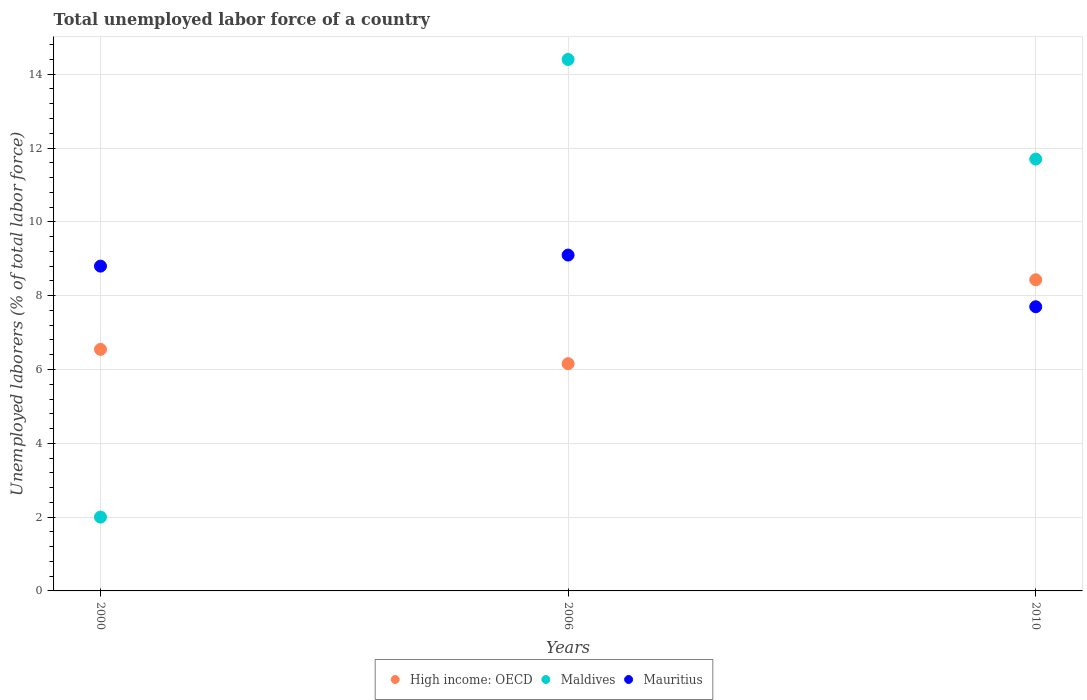How many different coloured dotlines are there?
Offer a very short reply. 3. What is the total unemployed labor force in Mauritius in 2010?
Your answer should be very brief. 7.7. Across all years, what is the maximum total unemployed labor force in High income: OECD?
Provide a succinct answer. 8.43. Across all years, what is the minimum total unemployed labor force in High income: OECD?
Ensure brevity in your answer.  6.16. In which year was the total unemployed labor force in Maldives maximum?
Your response must be concise. 2006. What is the total total unemployed labor force in Mauritius in the graph?
Your answer should be compact. 25.6. What is the difference between the total unemployed labor force in High income: OECD in 2000 and that in 2010?
Provide a short and direct response. -1.89. What is the difference between the total unemployed labor force in Maldives in 2000 and the total unemployed labor force in High income: OECD in 2010?
Your answer should be very brief. -6.43. What is the average total unemployed labor force in Mauritius per year?
Keep it short and to the point. 8.53. In the year 2006, what is the difference between the total unemployed labor force in Mauritius and total unemployed labor force in Maldives?
Provide a short and direct response. -5.3. In how many years, is the total unemployed labor force in High income: OECD greater than 10.4 %?
Ensure brevity in your answer.  0. What is the ratio of the total unemployed labor force in Mauritius in 2006 to that in 2010?
Provide a succinct answer. 1.18. Is the total unemployed labor force in Mauritius in 2006 less than that in 2010?
Make the answer very short. No. What is the difference between the highest and the second highest total unemployed labor force in High income: OECD?
Make the answer very short. 1.89. What is the difference between the highest and the lowest total unemployed labor force in High income: OECD?
Keep it short and to the point. 2.27. Is it the case that in every year, the sum of the total unemployed labor force in Mauritius and total unemployed labor force in High income: OECD  is greater than the total unemployed labor force in Maldives?
Provide a short and direct response. Yes. Does the total unemployed labor force in Maldives monotonically increase over the years?
Your answer should be very brief. No. Is the total unemployed labor force in High income: OECD strictly less than the total unemployed labor force in Mauritius over the years?
Your response must be concise. No. How many dotlines are there?
Offer a terse response. 3. How many years are there in the graph?
Make the answer very short. 3. What is the difference between two consecutive major ticks on the Y-axis?
Your answer should be very brief. 2. Does the graph contain any zero values?
Keep it short and to the point. No. What is the title of the graph?
Your answer should be compact. Total unemployed labor force of a country. What is the label or title of the X-axis?
Provide a succinct answer. Years. What is the label or title of the Y-axis?
Offer a very short reply. Unemployed laborers (% of total labor force). What is the Unemployed laborers (% of total labor force) in High income: OECD in 2000?
Offer a terse response. 6.54. What is the Unemployed laborers (% of total labor force) in Mauritius in 2000?
Give a very brief answer. 8.8. What is the Unemployed laborers (% of total labor force) in High income: OECD in 2006?
Ensure brevity in your answer.  6.16. What is the Unemployed laborers (% of total labor force) in Maldives in 2006?
Your answer should be very brief. 14.4. What is the Unemployed laborers (% of total labor force) in Mauritius in 2006?
Make the answer very short. 9.1. What is the Unemployed laborers (% of total labor force) of High income: OECD in 2010?
Your answer should be compact. 8.43. What is the Unemployed laborers (% of total labor force) in Maldives in 2010?
Provide a short and direct response. 11.7. What is the Unemployed laborers (% of total labor force) in Mauritius in 2010?
Offer a terse response. 7.7. Across all years, what is the maximum Unemployed laborers (% of total labor force) in High income: OECD?
Your answer should be compact. 8.43. Across all years, what is the maximum Unemployed laborers (% of total labor force) in Maldives?
Your answer should be compact. 14.4. Across all years, what is the maximum Unemployed laborers (% of total labor force) in Mauritius?
Provide a short and direct response. 9.1. Across all years, what is the minimum Unemployed laborers (% of total labor force) of High income: OECD?
Give a very brief answer. 6.16. Across all years, what is the minimum Unemployed laborers (% of total labor force) of Mauritius?
Offer a terse response. 7.7. What is the total Unemployed laborers (% of total labor force) in High income: OECD in the graph?
Keep it short and to the point. 21.13. What is the total Unemployed laborers (% of total labor force) in Maldives in the graph?
Your answer should be compact. 28.1. What is the total Unemployed laborers (% of total labor force) of Mauritius in the graph?
Provide a short and direct response. 25.6. What is the difference between the Unemployed laborers (% of total labor force) of High income: OECD in 2000 and that in 2006?
Provide a short and direct response. 0.39. What is the difference between the Unemployed laborers (% of total labor force) of Maldives in 2000 and that in 2006?
Your answer should be very brief. -12.4. What is the difference between the Unemployed laborers (% of total labor force) of High income: OECD in 2000 and that in 2010?
Give a very brief answer. -1.89. What is the difference between the Unemployed laborers (% of total labor force) in Maldives in 2000 and that in 2010?
Ensure brevity in your answer.  -9.7. What is the difference between the Unemployed laborers (% of total labor force) in Mauritius in 2000 and that in 2010?
Your answer should be very brief. 1.1. What is the difference between the Unemployed laborers (% of total labor force) of High income: OECD in 2006 and that in 2010?
Your response must be concise. -2.27. What is the difference between the Unemployed laborers (% of total labor force) in Maldives in 2006 and that in 2010?
Your response must be concise. 2.7. What is the difference between the Unemployed laborers (% of total labor force) of Mauritius in 2006 and that in 2010?
Make the answer very short. 1.4. What is the difference between the Unemployed laborers (% of total labor force) in High income: OECD in 2000 and the Unemployed laborers (% of total labor force) in Maldives in 2006?
Make the answer very short. -7.86. What is the difference between the Unemployed laborers (% of total labor force) in High income: OECD in 2000 and the Unemployed laborers (% of total labor force) in Mauritius in 2006?
Ensure brevity in your answer.  -2.56. What is the difference between the Unemployed laborers (% of total labor force) of High income: OECD in 2000 and the Unemployed laborers (% of total labor force) of Maldives in 2010?
Keep it short and to the point. -5.16. What is the difference between the Unemployed laborers (% of total labor force) in High income: OECD in 2000 and the Unemployed laborers (% of total labor force) in Mauritius in 2010?
Your response must be concise. -1.16. What is the difference between the Unemployed laborers (% of total labor force) in High income: OECD in 2006 and the Unemployed laborers (% of total labor force) in Maldives in 2010?
Provide a short and direct response. -5.54. What is the difference between the Unemployed laborers (% of total labor force) of High income: OECD in 2006 and the Unemployed laborers (% of total labor force) of Mauritius in 2010?
Ensure brevity in your answer.  -1.54. What is the average Unemployed laborers (% of total labor force) in High income: OECD per year?
Your answer should be very brief. 7.04. What is the average Unemployed laborers (% of total labor force) of Maldives per year?
Your response must be concise. 9.37. What is the average Unemployed laborers (% of total labor force) in Mauritius per year?
Ensure brevity in your answer.  8.53. In the year 2000, what is the difference between the Unemployed laborers (% of total labor force) in High income: OECD and Unemployed laborers (% of total labor force) in Maldives?
Offer a very short reply. 4.54. In the year 2000, what is the difference between the Unemployed laborers (% of total labor force) in High income: OECD and Unemployed laborers (% of total labor force) in Mauritius?
Your response must be concise. -2.26. In the year 2006, what is the difference between the Unemployed laborers (% of total labor force) of High income: OECD and Unemployed laborers (% of total labor force) of Maldives?
Make the answer very short. -8.24. In the year 2006, what is the difference between the Unemployed laborers (% of total labor force) in High income: OECD and Unemployed laborers (% of total labor force) in Mauritius?
Your response must be concise. -2.94. In the year 2010, what is the difference between the Unemployed laborers (% of total labor force) in High income: OECD and Unemployed laborers (% of total labor force) in Maldives?
Offer a terse response. -3.27. In the year 2010, what is the difference between the Unemployed laborers (% of total labor force) in High income: OECD and Unemployed laborers (% of total labor force) in Mauritius?
Your response must be concise. 0.73. In the year 2010, what is the difference between the Unemployed laborers (% of total labor force) of Maldives and Unemployed laborers (% of total labor force) of Mauritius?
Your answer should be compact. 4. What is the ratio of the Unemployed laborers (% of total labor force) in High income: OECD in 2000 to that in 2006?
Your answer should be compact. 1.06. What is the ratio of the Unemployed laborers (% of total labor force) in Maldives in 2000 to that in 2006?
Make the answer very short. 0.14. What is the ratio of the Unemployed laborers (% of total labor force) in High income: OECD in 2000 to that in 2010?
Your answer should be very brief. 0.78. What is the ratio of the Unemployed laborers (% of total labor force) in Maldives in 2000 to that in 2010?
Ensure brevity in your answer.  0.17. What is the ratio of the Unemployed laborers (% of total labor force) in High income: OECD in 2006 to that in 2010?
Give a very brief answer. 0.73. What is the ratio of the Unemployed laborers (% of total labor force) in Maldives in 2006 to that in 2010?
Give a very brief answer. 1.23. What is the ratio of the Unemployed laborers (% of total labor force) of Mauritius in 2006 to that in 2010?
Your answer should be compact. 1.18. What is the difference between the highest and the second highest Unemployed laborers (% of total labor force) of High income: OECD?
Your answer should be compact. 1.89. What is the difference between the highest and the second highest Unemployed laborers (% of total labor force) of Maldives?
Your answer should be very brief. 2.7. What is the difference between the highest and the second highest Unemployed laborers (% of total labor force) in Mauritius?
Give a very brief answer. 0.3. What is the difference between the highest and the lowest Unemployed laborers (% of total labor force) of High income: OECD?
Your response must be concise. 2.27. What is the difference between the highest and the lowest Unemployed laborers (% of total labor force) of Maldives?
Provide a succinct answer. 12.4. 